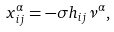Convert formula to latex. <formula><loc_0><loc_0><loc_500><loc_500>x _ { i j } ^ { \alpha } = - \sigma h _ { i j } \nu ^ { \alpha } ,</formula> 